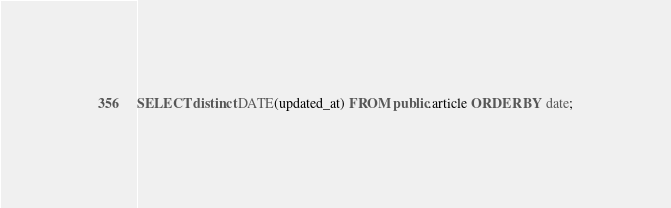Convert code to text. <code><loc_0><loc_0><loc_500><loc_500><_SQL_>SELECT distinct DATE(updated_at) FROM public.article ORDER BY date;
</code> 